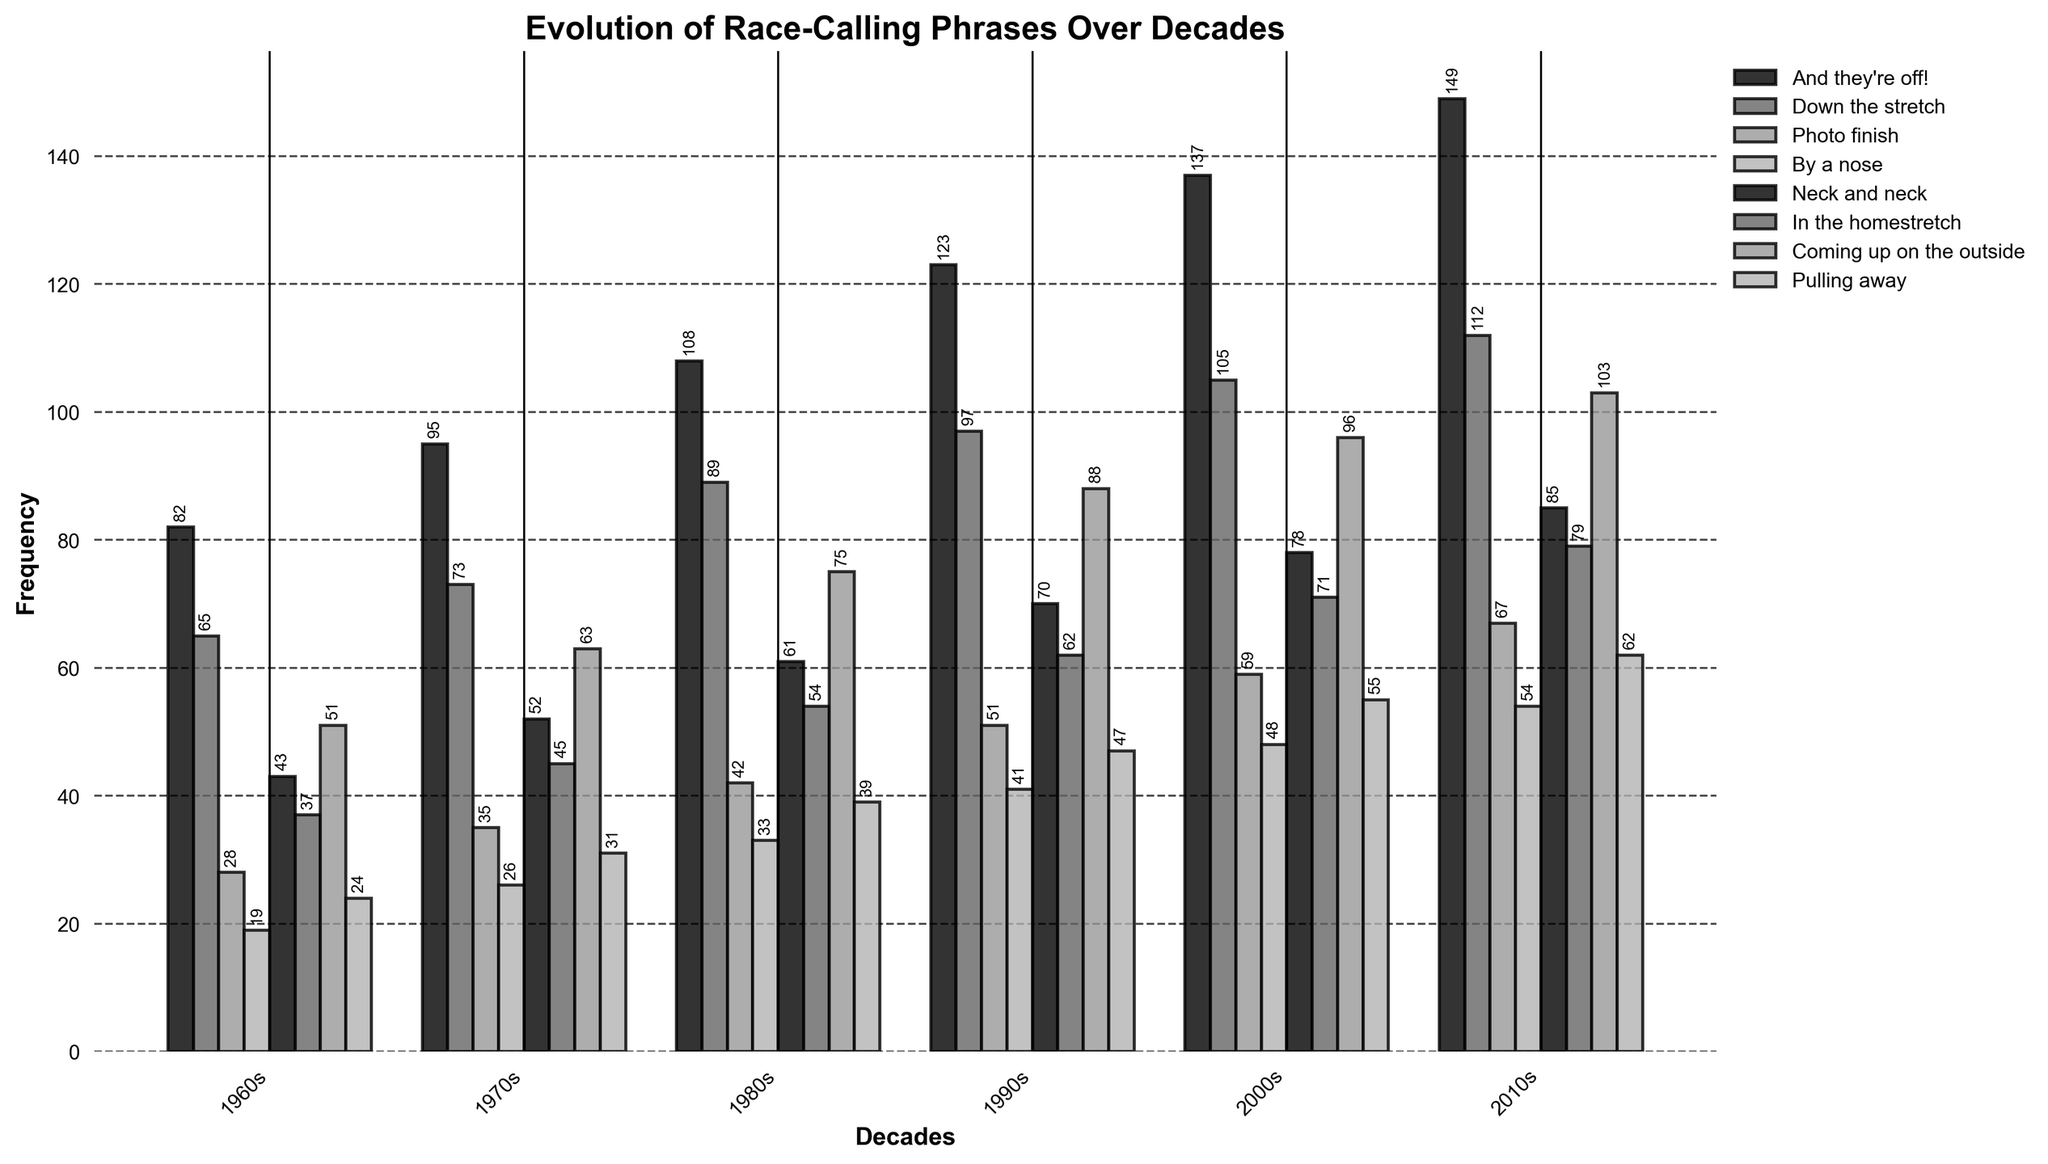What race-calling phrase was used most frequently in the 2010s? To answer this, look at the bar heights for each phrase in the 2010s. "And they're off!" has the tallest bar, indicating the highest frequency.
Answer: "And they're off!" Which phrase had the largest increase in frequency from the 1960s to the 2010s? Identify the difference in frequency for each phrase between the 1960s and the 2010s. "And they're off!" increased from 82 to 149, which is the largest increase.
Answer: "And they're off!" Between which two decades did the phrase "Photo finish" see the biggest jump in use? Look at the bar heights for "Photo finish" across all decades. The biggest increase is from the 1990s (51) to 2000s (59).
Answer: 1990s to 2000s What is the average frequency of the phrase "Neck and neck" over the six decades? Add up the frequencies of "Neck and neck" across all decades (43 + 52 + 61 + 70 + 78 + 85) and divide by 6.
Answer: 64.83 Which decade saw the lowest usage of the phrase "In the homestretch"? Look for the shortest bar for "In the homestretch". The 1960s had the lowest frequency of 37.
Answer: 1960s By how much did the usage of "Pulling away" increase from the 1970s to the 2000s? Subtract the frequency in the 1970s (31) from the 2000s (55).
Answer: 24 Which phrases had equal frequency in any decade, and in which decade did this occur? Compare the bar heights for all phrases across each decade. "In the homestretch" and "Coming up on the outside" are equal at 51 in the 1980s.
Answer: "In the homestretch" and "Coming up on the outside" in the 1980s How does the usage of "Down the stretch" in the 1990s compare to the average usage of this phrase across all decades? Find the average of "Down the stretch" (65+73+89+97+105+112)/6 = 90.17. The 1990s had 97, which is above average.
Answer: Above average Which phrase showed the most consistent increase in usage over the decades? Identify the phrases whose bars consistently increase in height across all decades. "And they're off!" showed a consistent increase every decade.
Answer: "And they're off!" 